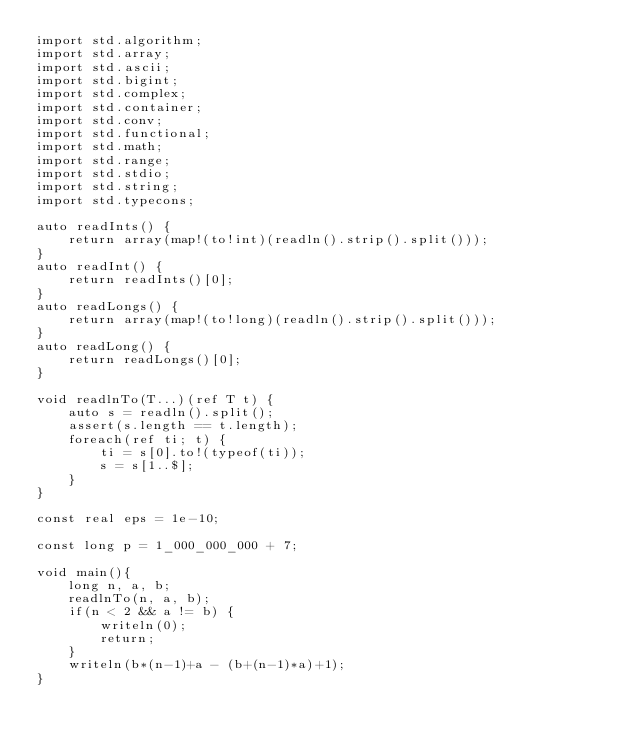<code> <loc_0><loc_0><loc_500><loc_500><_D_>import std.algorithm;
import std.array;
import std.ascii;
import std.bigint;
import std.complex;
import std.container;
import std.conv;
import std.functional;
import std.math;
import std.range;
import std.stdio;
import std.string;
import std.typecons;

auto readInts() {
	return array(map!(to!int)(readln().strip().split()));
}
auto readInt() {
	return readInts()[0];
}
auto readLongs() {
	return array(map!(to!long)(readln().strip().split()));
}
auto readLong() {
	return readLongs()[0];
}

void readlnTo(T...)(ref T t) {
    auto s = readln().split();
    assert(s.length == t.length);
    foreach(ref ti; t) {
        ti = s[0].to!(typeof(ti));
        s = s[1..$];
    }
}

const real eps = 1e-10;

const long p = 1_000_000_000 + 7;

void main(){
    long n, a, b;
    readlnTo(n, a, b);
    if(n < 2 && a != b) {
        writeln(0);
        return;
    }
    writeln(b*(n-1)+a - (b+(n-1)*a)+1);
}

</code> 